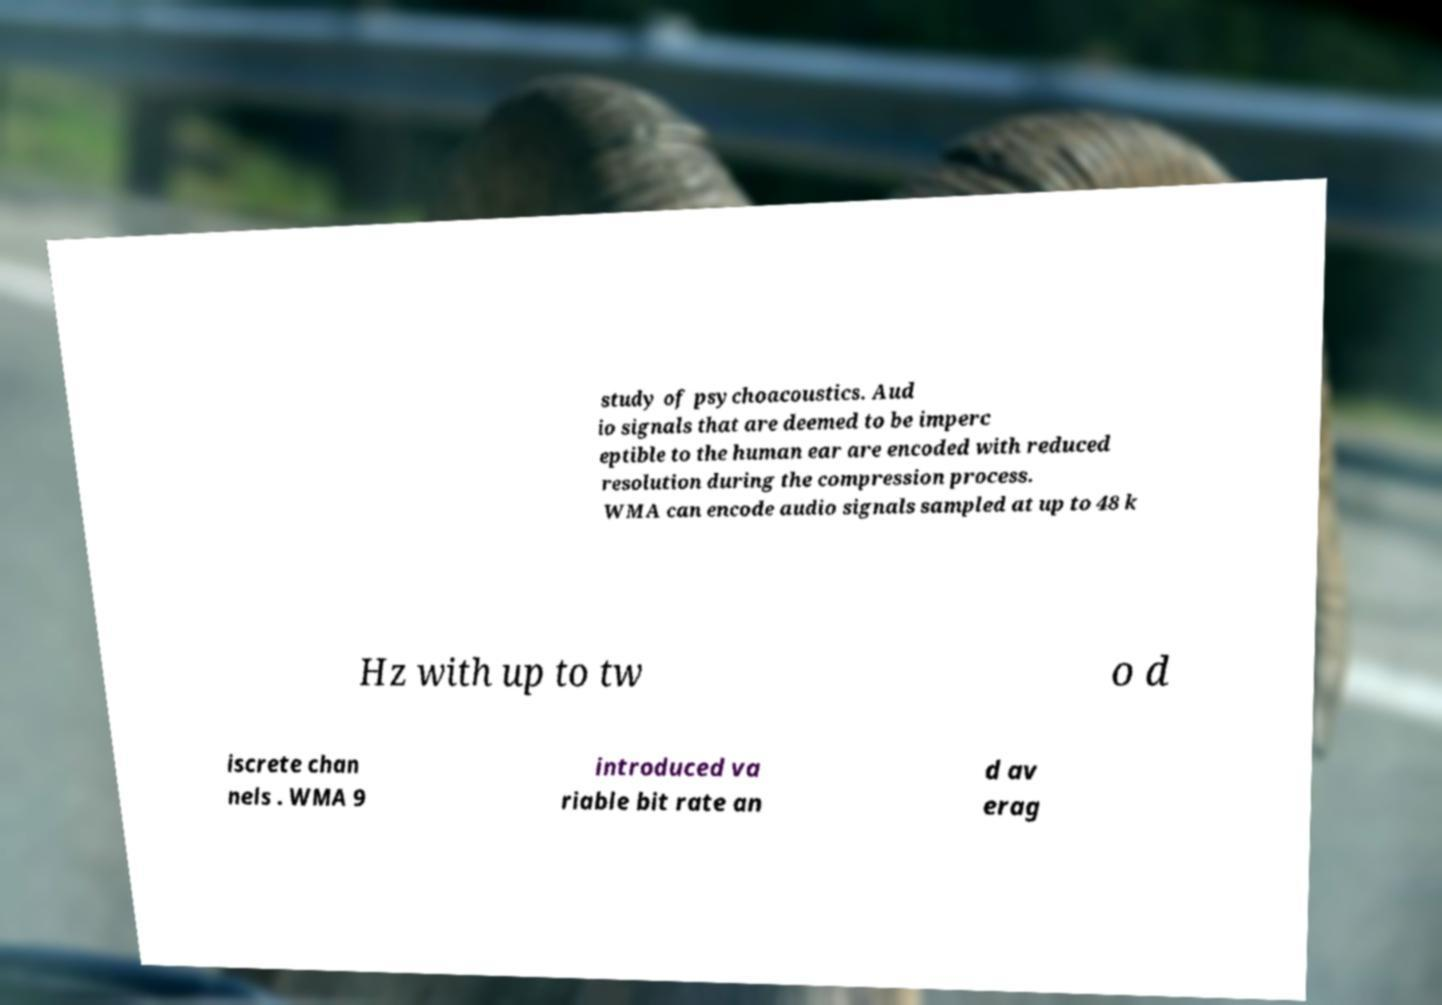There's text embedded in this image that I need extracted. Can you transcribe it verbatim? study of psychoacoustics. Aud io signals that are deemed to be imperc eptible to the human ear are encoded with reduced resolution during the compression process. WMA can encode audio signals sampled at up to 48 k Hz with up to tw o d iscrete chan nels . WMA 9 introduced va riable bit rate an d av erag 